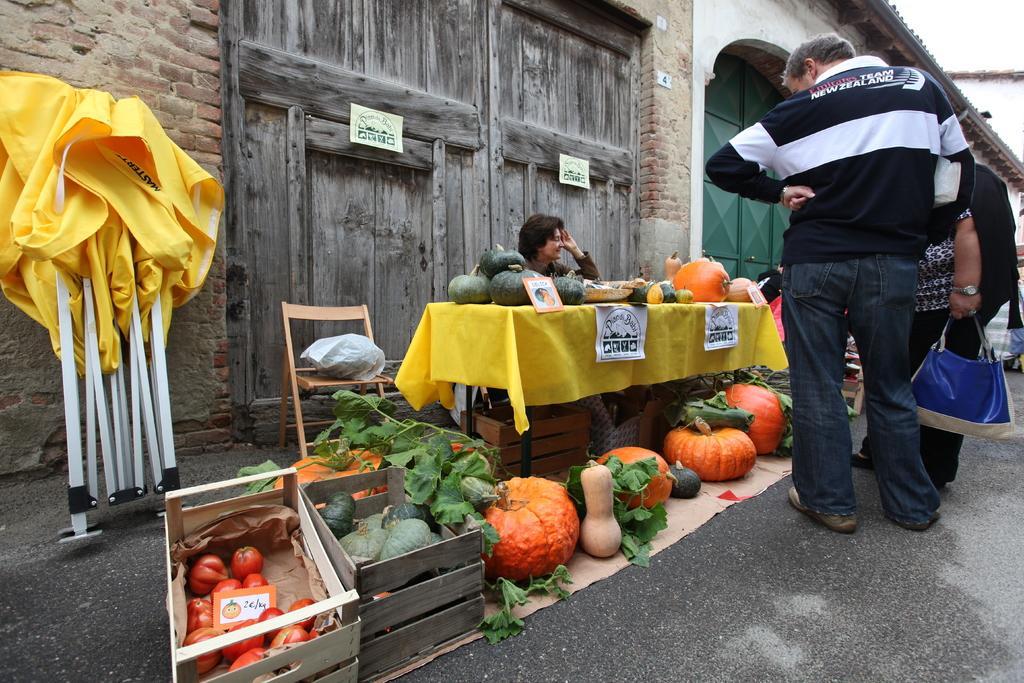Can you describe this image briefly? In this image we can see a person sitting on chair and selling some pumpkins, calabazas which are on table and there are some persons standing and buying those and at the background of the image there is wall, door and some yellow tent. 